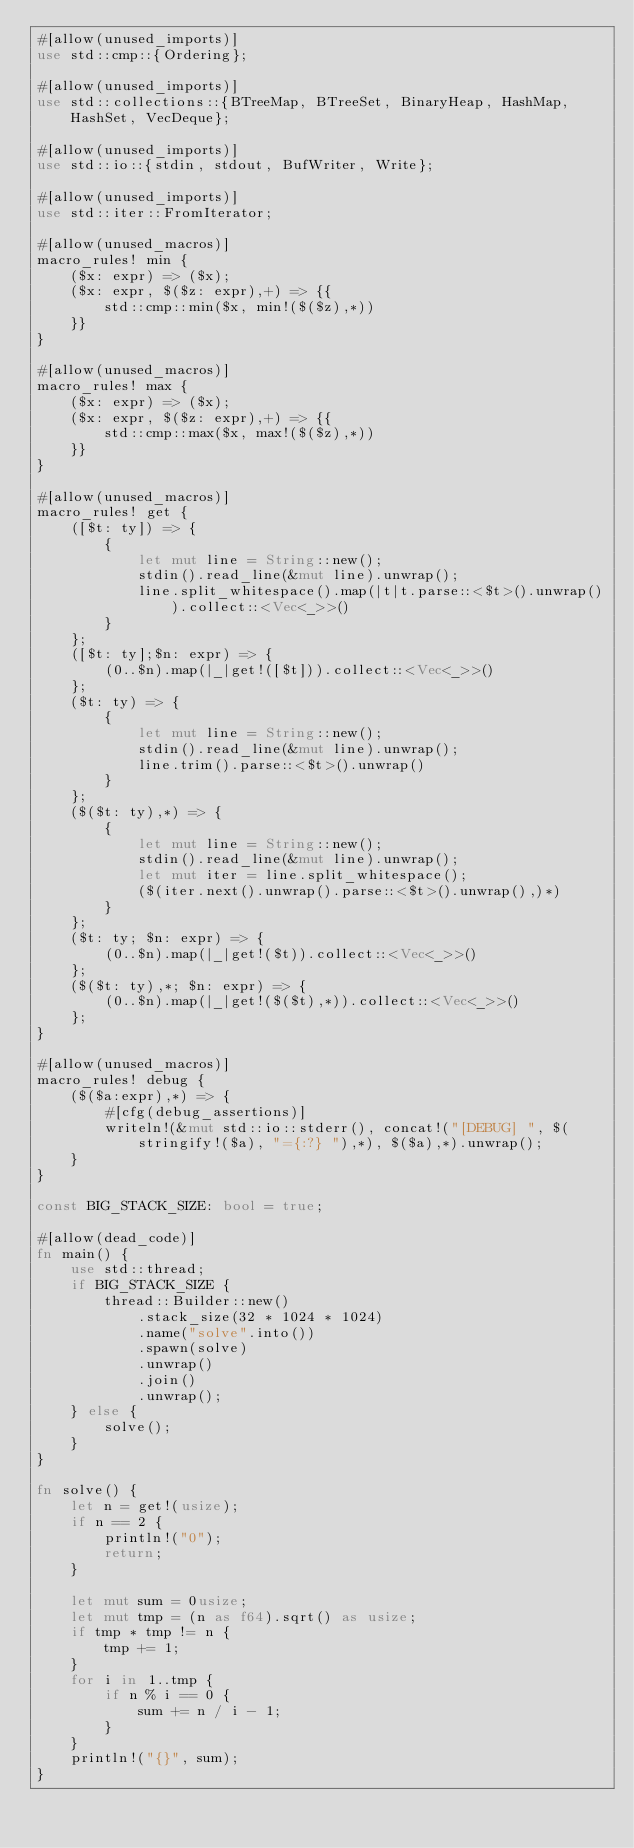Convert code to text. <code><loc_0><loc_0><loc_500><loc_500><_Rust_>#[allow(unused_imports)]
use std::cmp::{Ordering};

#[allow(unused_imports)]
use std::collections::{BTreeMap, BTreeSet, BinaryHeap, HashMap, HashSet, VecDeque};

#[allow(unused_imports)]
use std::io::{stdin, stdout, BufWriter, Write};

#[allow(unused_imports)]
use std::iter::FromIterator;

#[allow(unused_macros)]
macro_rules! min {
    ($x: expr) => ($x);
    ($x: expr, $($z: expr),+) => {{
        std::cmp::min($x, min!($($z),*))
    }}
}

#[allow(unused_macros)]
macro_rules! max {
    ($x: expr) => ($x);
    ($x: expr, $($z: expr),+) => {{
        std::cmp::max($x, max!($($z),*))
    }}
}

#[allow(unused_macros)]
macro_rules! get { 
    ([$t: ty]) => { 
        { 
            let mut line = String::new(); 
            stdin().read_line(&mut line).unwrap(); 
            line.split_whitespace().map(|t|t.parse::<$t>().unwrap()).collect::<Vec<_>>()
        }
    };
    ([$t: ty];$n: expr) => {
        (0..$n).map(|_|get!([$t])).collect::<Vec<_>>()
    };
    ($t: ty) => {
        {
            let mut line = String::new();
            stdin().read_line(&mut line).unwrap();
            line.trim().parse::<$t>().unwrap()
        }
    };
    ($($t: ty),*) => {
        { 
            let mut line = String::new();
            stdin().read_line(&mut line).unwrap();
            let mut iter = line.split_whitespace();
            ($(iter.next().unwrap().parse::<$t>().unwrap(),)*)
        }
    };
    ($t: ty; $n: expr) => {
        (0..$n).map(|_|get!($t)).collect::<Vec<_>>()
    };
    ($($t: ty),*; $n: expr) => {
        (0..$n).map(|_|get!($($t),*)).collect::<Vec<_>>()
    };
}

#[allow(unused_macros)]
macro_rules! debug {
    ($($a:expr),*) => {
        #[cfg(debug_assertions)]
        writeln!(&mut std::io::stderr(), concat!("[DEBUG] ", $(stringify!($a), "={:?} "),*), $($a),*).unwrap();
    }
}

const BIG_STACK_SIZE: bool = true;

#[allow(dead_code)]
fn main() {
    use std::thread;
    if BIG_STACK_SIZE {
        thread::Builder::new()
            .stack_size(32 * 1024 * 1024)
            .name("solve".into())
            .spawn(solve)
            .unwrap()
            .join()
            .unwrap();
    } else {
        solve();
    }
}

fn solve() {
    let n = get!(usize);
    if n == 2 {
        println!("0");
        return;
    }

    let mut sum = 0usize;
    let mut tmp = (n as f64).sqrt() as usize;
    if tmp * tmp != n {
        tmp += 1;
    }
    for i in 1..tmp {
        if n % i == 0 {
            sum += n / i - 1;
        }
    }
    println!("{}", sum);
}
</code> 